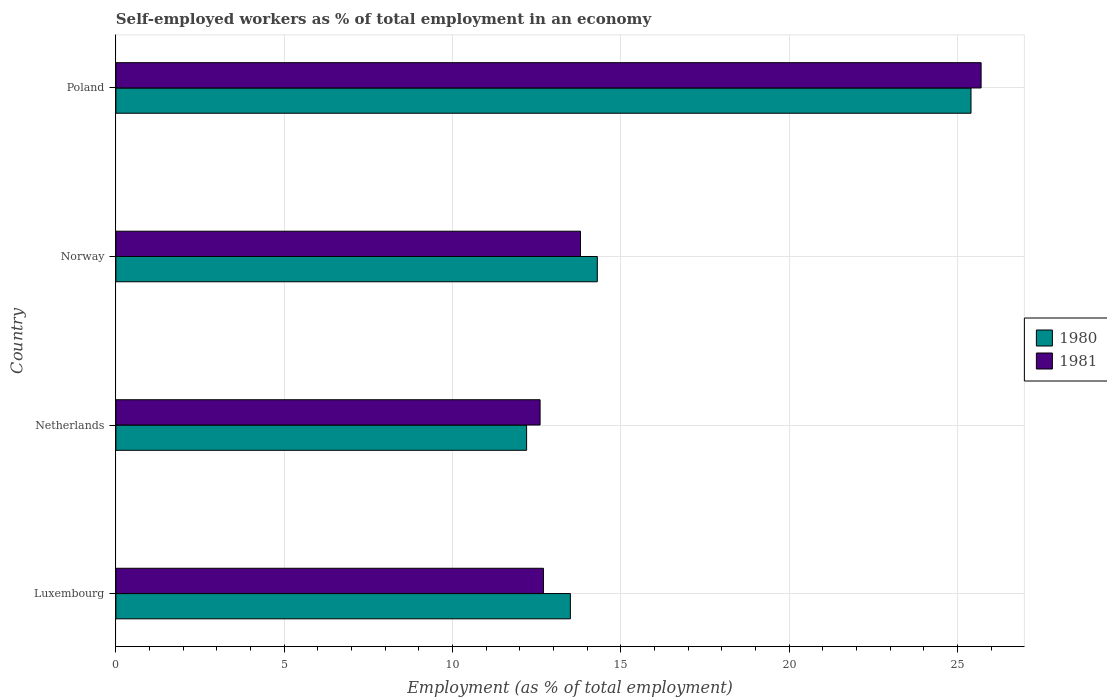Are the number of bars on each tick of the Y-axis equal?
Offer a terse response. Yes. In how many cases, is the number of bars for a given country not equal to the number of legend labels?
Your response must be concise. 0. What is the percentage of self-employed workers in 1981 in Norway?
Make the answer very short. 13.8. Across all countries, what is the maximum percentage of self-employed workers in 1980?
Provide a succinct answer. 25.4. Across all countries, what is the minimum percentage of self-employed workers in 1981?
Keep it short and to the point. 12.6. In which country was the percentage of self-employed workers in 1980 maximum?
Your response must be concise. Poland. What is the total percentage of self-employed workers in 1980 in the graph?
Offer a very short reply. 65.4. What is the difference between the percentage of self-employed workers in 1981 in Luxembourg and that in Poland?
Keep it short and to the point. -13. What is the difference between the percentage of self-employed workers in 1981 in Poland and the percentage of self-employed workers in 1980 in Netherlands?
Give a very brief answer. 13.5. What is the average percentage of self-employed workers in 1981 per country?
Ensure brevity in your answer.  16.2. What is the difference between the percentage of self-employed workers in 1980 and percentage of self-employed workers in 1981 in Luxembourg?
Your response must be concise. 0.8. What is the ratio of the percentage of self-employed workers in 1981 in Netherlands to that in Norway?
Provide a succinct answer. 0.91. Is the percentage of self-employed workers in 1981 in Netherlands less than that in Norway?
Offer a very short reply. Yes. Is the difference between the percentage of self-employed workers in 1980 in Norway and Poland greater than the difference between the percentage of self-employed workers in 1981 in Norway and Poland?
Keep it short and to the point. Yes. What is the difference between the highest and the second highest percentage of self-employed workers in 1981?
Ensure brevity in your answer.  11.9. What is the difference between the highest and the lowest percentage of self-employed workers in 1981?
Your answer should be compact. 13.1. In how many countries, is the percentage of self-employed workers in 1981 greater than the average percentage of self-employed workers in 1981 taken over all countries?
Your response must be concise. 1. Is the sum of the percentage of self-employed workers in 1980 in Netherlands and Poland greater than the maximum percentage of self-employed workers in 1981 across all countries?
Give a very brief answer. Yes. What does the 2nd bar from the bottom in Poland represents?
Your response must be concise. 1981. Are all the bars in the graph horizontal?
Your response must be concise. Yes. Are the values on the major ticks of X-axis written in scientific E-notation?
Ensure brevity in your answer.  No. Does the graph contain any zero values?
Provide a short and direct response. No. Where does the legend appear in the graph?
Give a very brief answer. Center right. How are the legend labels stacked?
Offer a terse response. Vertical. What is the title of the graph?
Provide a short and direct response. Self-employed workers as % of total employment in an economy. What is the label or title of the X-axis?
Provide a succinct answer. Employment (as % of total employment). What is the label or title of the Y-axis?
Keep it short and to the point. Country. What is the Employment (as % of total employment) of 1980 in Luxembourg?
Give a very brief answer. 13.5. What is the Employment (as % of total employment) in 1981 in Luxembourg?
Offer a very short reply. 12.7. What is the Employment (as % of total employment) in 1980 in Netherlands?
Offer a very short reply. 12.2. What is the Employment (as % of total employment) in 1981 in Netherlands?
Your answer should be compact. 12.6. What is the Employment (as % of total employment) of 1980 in Norway?
Provide a short and direct response. 14.3. What is the Employment (as % of total employment) of 1981 in Norway?
Keep it short and to the point. 13.8. What is the Employment (as % of total employment) of 1980 in Poland?
Offer a terse response. 25.4. What is the Employment (as % of total employment) of 1981 in Poland?
Provide a short and direct response. 25.7. Across all countries, what is the maximum Employment (as % of total employment) in 1980?
Offer a very short reply. 25.4. Across all countries, what is the maximum Employment (as % of total employment) of 1981?
Make the answer very short. 25.7. Across all countries, what is the minimum Employment (as % of total employment) of 1980?
Your response must be concise. 12.2. Across all countries, what is the minimum Employment (as % of total employment) of 1981?
Your response must be concise. 12.6. What is the total Employment (as % of total employment) of 1980 in the graph?
Offer a very short reply. 65.4. What is the total Employment (as % of total employment) in 1981 in the graph?
Your response must be concise. 64.8. What is the difference between the Employment (as % of total employment) of 1980 in Luxembourg and that in Netherlands?
Keep it short and to the point. 1.3. What is the difference between the Employment (as % of total employment) of 1980 in Luxembourg and that in Poland?
Make the answer very short. -11.9. What is the difference between the Employment (as % of total employment) in 1981 in Netherlands and that in Norway?
Ensure brevity in your answer.  -1.2. What is the difference between the Employment (as % of total employment) in 1981 in Netherlands and that in Poland?
Your response must be concise. -13.1. What is the difference between the Employment (as % of total employment) of 1980 in Luxembourg and the Employment (as % of total employment) of 1981 in Netherlands?
Provide a succinct answer. 0.9. What is the difference between the Employment (as % of total employment) in 1980 in Netherlands and the Employment (as % of total employment) in 1981 in Poland?
Offer a very short reply. -13.5. What is the average Employment (as % of total employment) in 1980 per country?
Offer a very short reply. 16.35. What is the average Employment (as % of total employment) of 1981 per country?
Make the answer very short. 16.2. What is the difference between the Employment (as % of total employment) of 1980 and Employment (as % of total employment) of 1981 in Luxembourg?
Keep it short and to the point. 0.8. What is the ratio of the Employment (as % of total employment) of 1980 in Luxembourg to that in Netherlands?
Your response must be concise. 1.11. What is the ratio of the Employment (as % of total employment) in 1981 in Luxembourg to that in Netherlands?
Ensure brevity in your answer.  1.01. What is the ratio of the Employment (as % of total employment) of 1980 in Luxembourg to that in Norway?
Provide a short and direct response. 0.94. What is the ratio of the Employment (as % of total employment) of 1981 in Luxembourg to that in Norway?
Ensure brevity in your answer.  0.92. What is the ratio of the Employment (as % of total employment) of 1980 in Luxembourg to that in Poland?
Provide a short and direct response. 0.53. What is the ratio of the Employment (as % of total employment) in 1981 in Luxembourg to that in Poland?
Provide a short and direct response. 0.49. What is the ratio of the Employment (as % of total employment) of 1980 in Netherlands to that in Norway?
Offer a very short reply. 0.85. What is the ratio of the Employment (as % of total employment) in 1981 in Netherlands to that in Norway?
Make the answer very short. 0.91. What is the ratio of the Employment (as % of total employment) of 1980 in Netherlands to that in Poland?
Ensure brevity in your answer.  0.48. What is the ratio of the Employment (as % of total employment) in 1981 in Netherlands to that in Poland?
Keep it short and to the point. 0.49. What is the ratio of the Employment (as % of total employment) of 1980 in Norway to that in Poland?
Provide a short and direct response. 0.56. What is the ratio of the Employment (as % of total employment) in 1981 in Norway to that in Poland?
Provide a succinct answer. 0.54. What is the difference between the highest and the second highest Employment (as % of total employment) of 1981?
Make the answer very short. 11.9. What is the difference between the highest and the lowest Employment (as % of total employment) in 1980?
Ensure brevity in your answer.  13.2. 